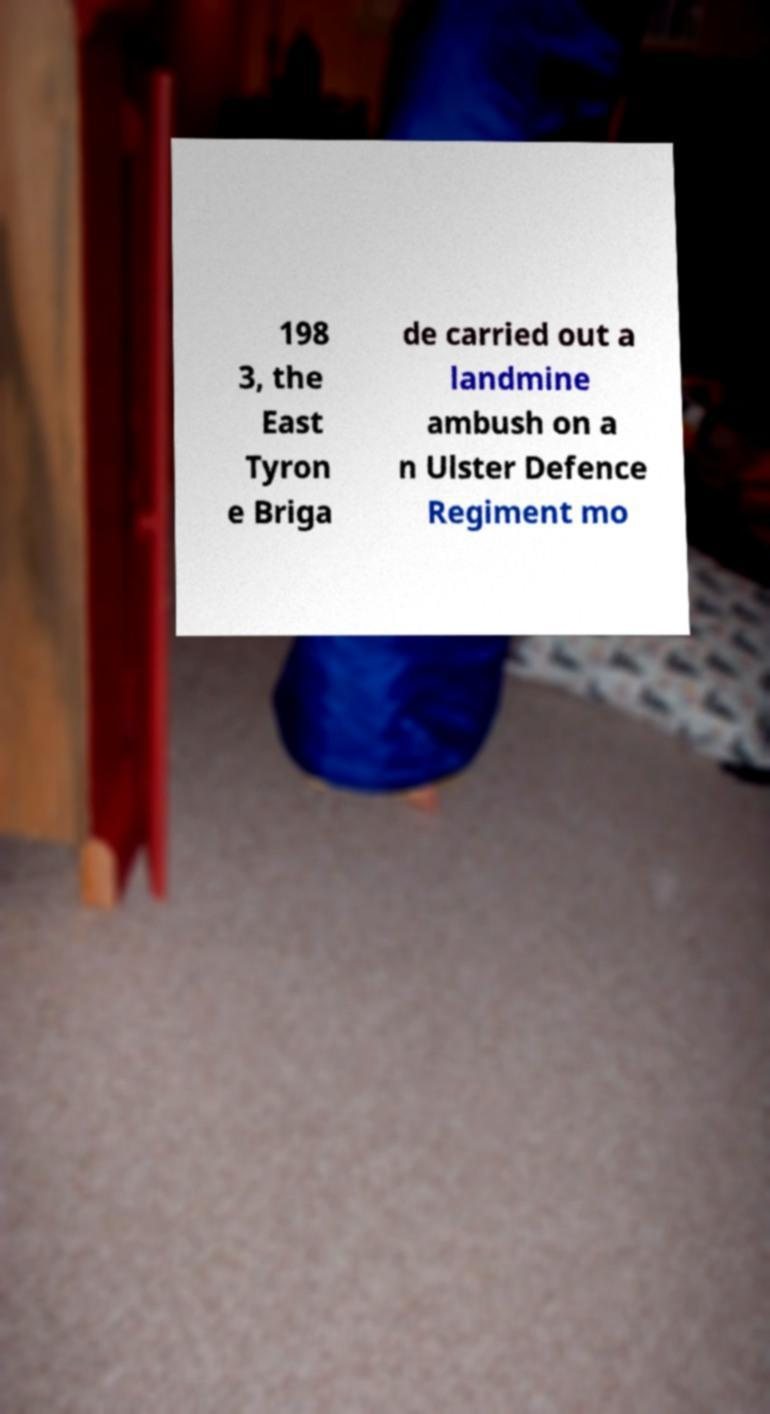I need the written content from this picture converted into text. Can you do that? 198 3, the East Tyron e Briga de carried out a landmine ambush on a n Ulster Defence Regiment mo 